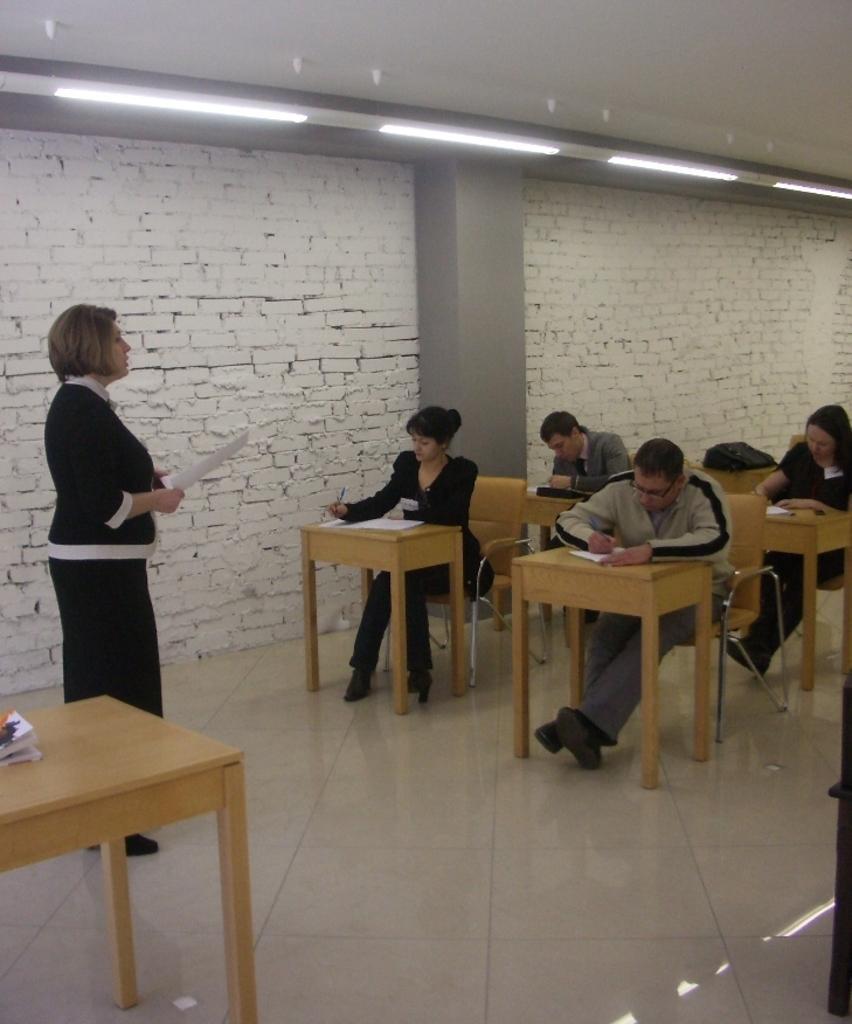In one or two sentences, can you explain what this image depicts? As we can see in the image there is a brick wall, few people sitting on chairs and there are tables. On tables there are papers. 